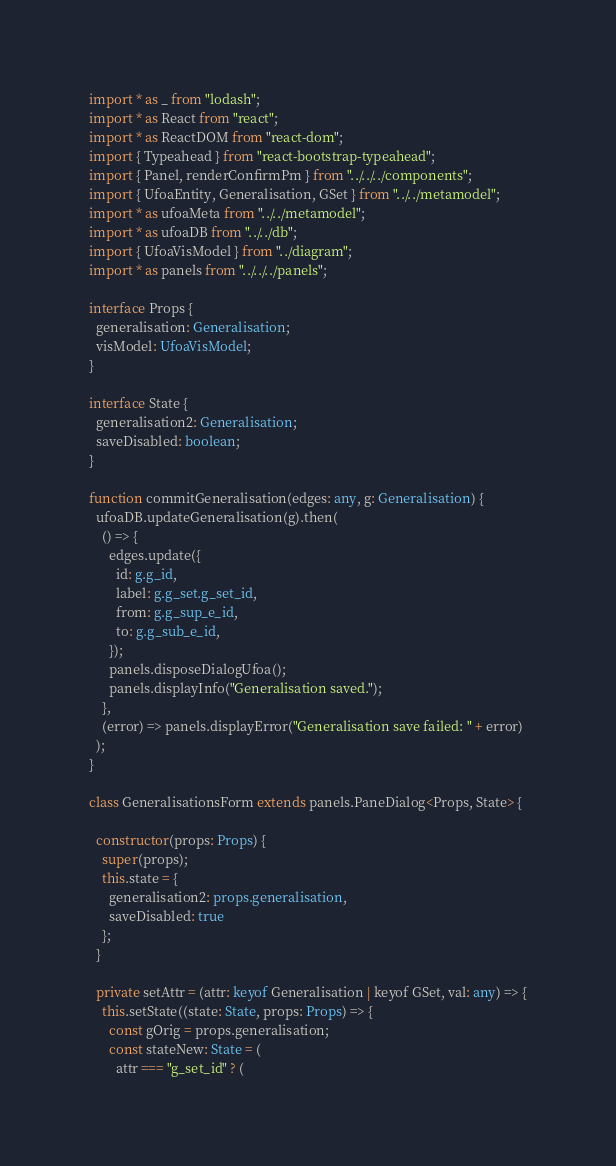<code> <loc_0><loc_0><loc_500><loc_500><_TypeScript_>import * as _ from "lodash";
import * as React from "react";
import * as ReactDOM from "react-dom";
import { Typeahead } from "react-bootstrap-typeahead";
import { Panel, renderConfirmPm } from "../../../components";
import { UfoaEntity, Generalisation, GSet } from "../../metamodel";
import * as ufoaMeta from "../../metamodel";
import * as ufoaDB from "../../db";
import { UfoaVisModel } from "../diagram";
import * as panels from "../../../panels";

interface Props {
  generalisation: Generalisation;
  visModel: UfoaVisModel;
}

interface State {
  generalisation2: Generalisation;
  saveDisabled: boolean;
}

function commitGeneralisation(edges: any, g: Generalisation) {
  ufoaDB.updateGeneralisation(g).then(
    () => {
      edges.update({
        id: g.g_id,
        label: g.g_set.g_set_id,
        from: g.g_sup_e_id,
        to: g.g_sub_e_id,
      });
      panels.disposeDialogUfoa();
      panels.displayInfo("Generalisation saved.");
    },
    (error) => panels.displayError("Generalisation save failed: " + error)
  );
}

class GeneralisationsForm extends panels.PaneDialog<Props, State> {

  constructor(props: Props) {
    super(props);
    this.state = {
      generalisation2: props.generalisation,
      saveDisabled: true
    };
  }

  private setAttr = (attr: keyof Generalisation | keyof GSet, val: any) => {
    this.setState((state: State, props: Props) => {
      const gOrig = props.generalisation;
      const stateNew: State = (
        attr === "g_set_id" ? (</code> 